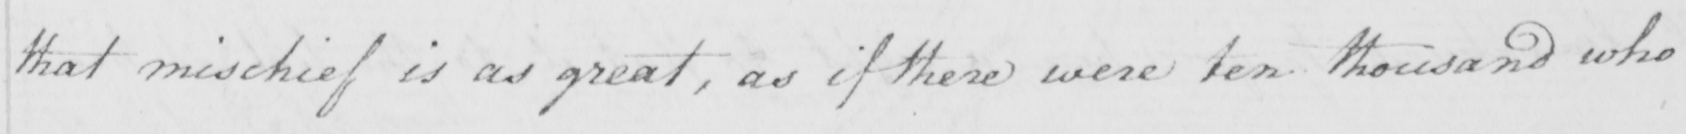Please transcribe the handwritten text in this image. that mischief is as great , as if there were ten thousand who 